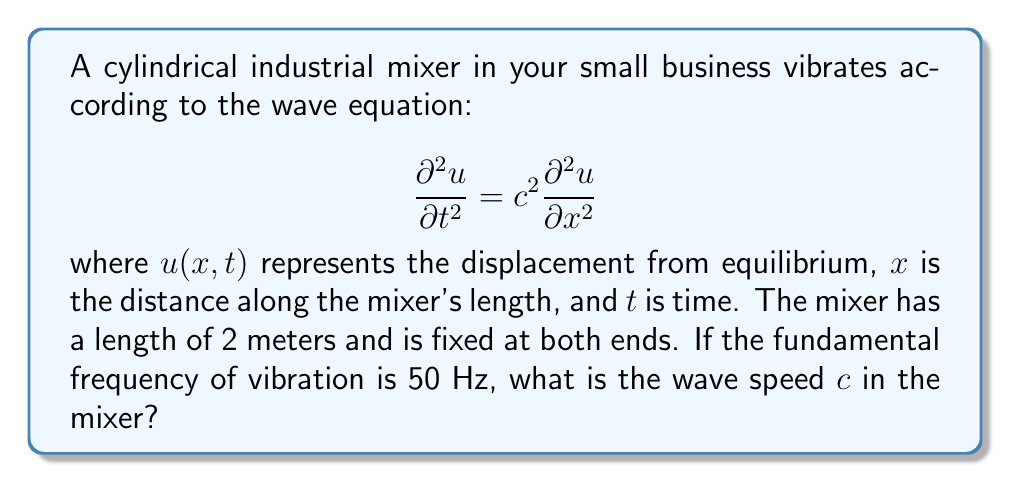What is the answer to this math problem? Let's approach this step-by-step:

1) For a string (or in this case, a cylindrical mixer) fixed at both ends, the fundamental frequency $f_1$ is given by:

   $$f_1 = \frac{c}{2L}$$

   where $c$ is the wave speed and $L$ is the length of the mixer.

2) We are given that the fundamental frequency $f_1 = 50$ Hz and the length $L = 2$ meters.

3) Substituting these values into the equation:

   $$50 = \frac{c}{2(2)}$$

4) Simplify:

   $$50 = \frac{c}{4}$$

5) Multiply both sides by 4:

   $$200 = c$$

Therefore, the wave speed in the mixer is 200 m/s.
Answer: $c = 200$ m/s 